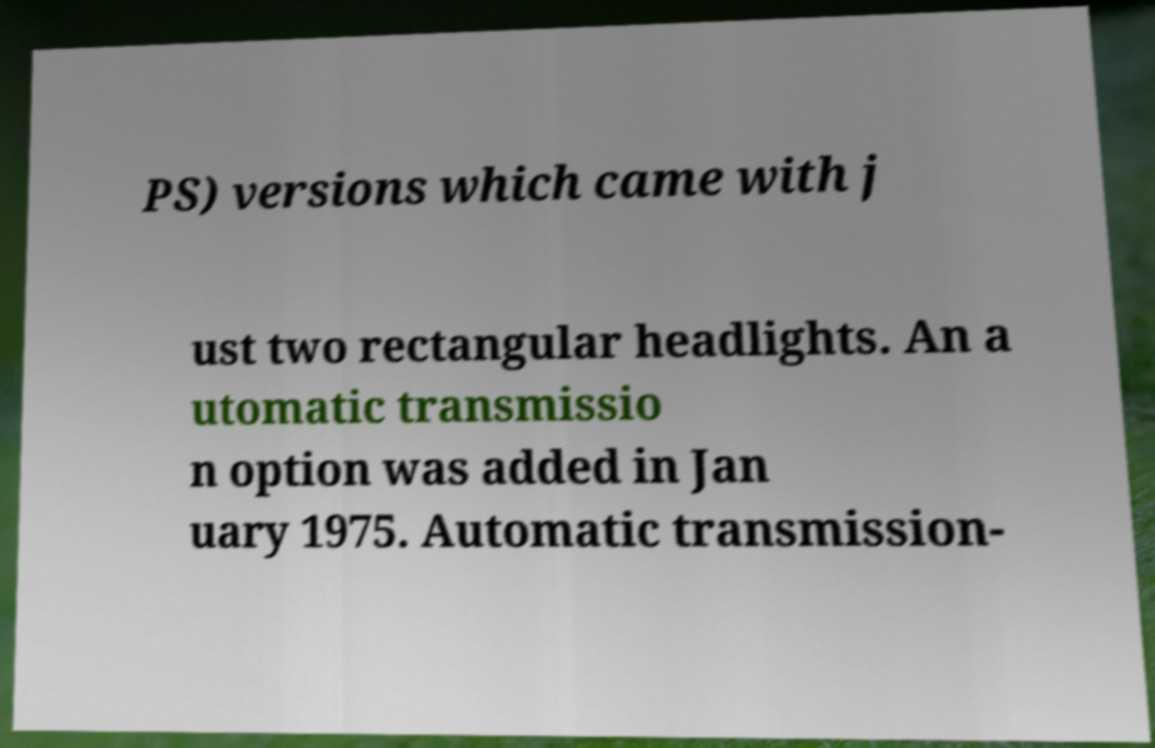Can you accurately transcribe the text from the provided image for me? PS) versions which came with j ust two rectangular headlights. An a utomatic transmissio n option was added in Jan uary 1975. Automatic transmission- 